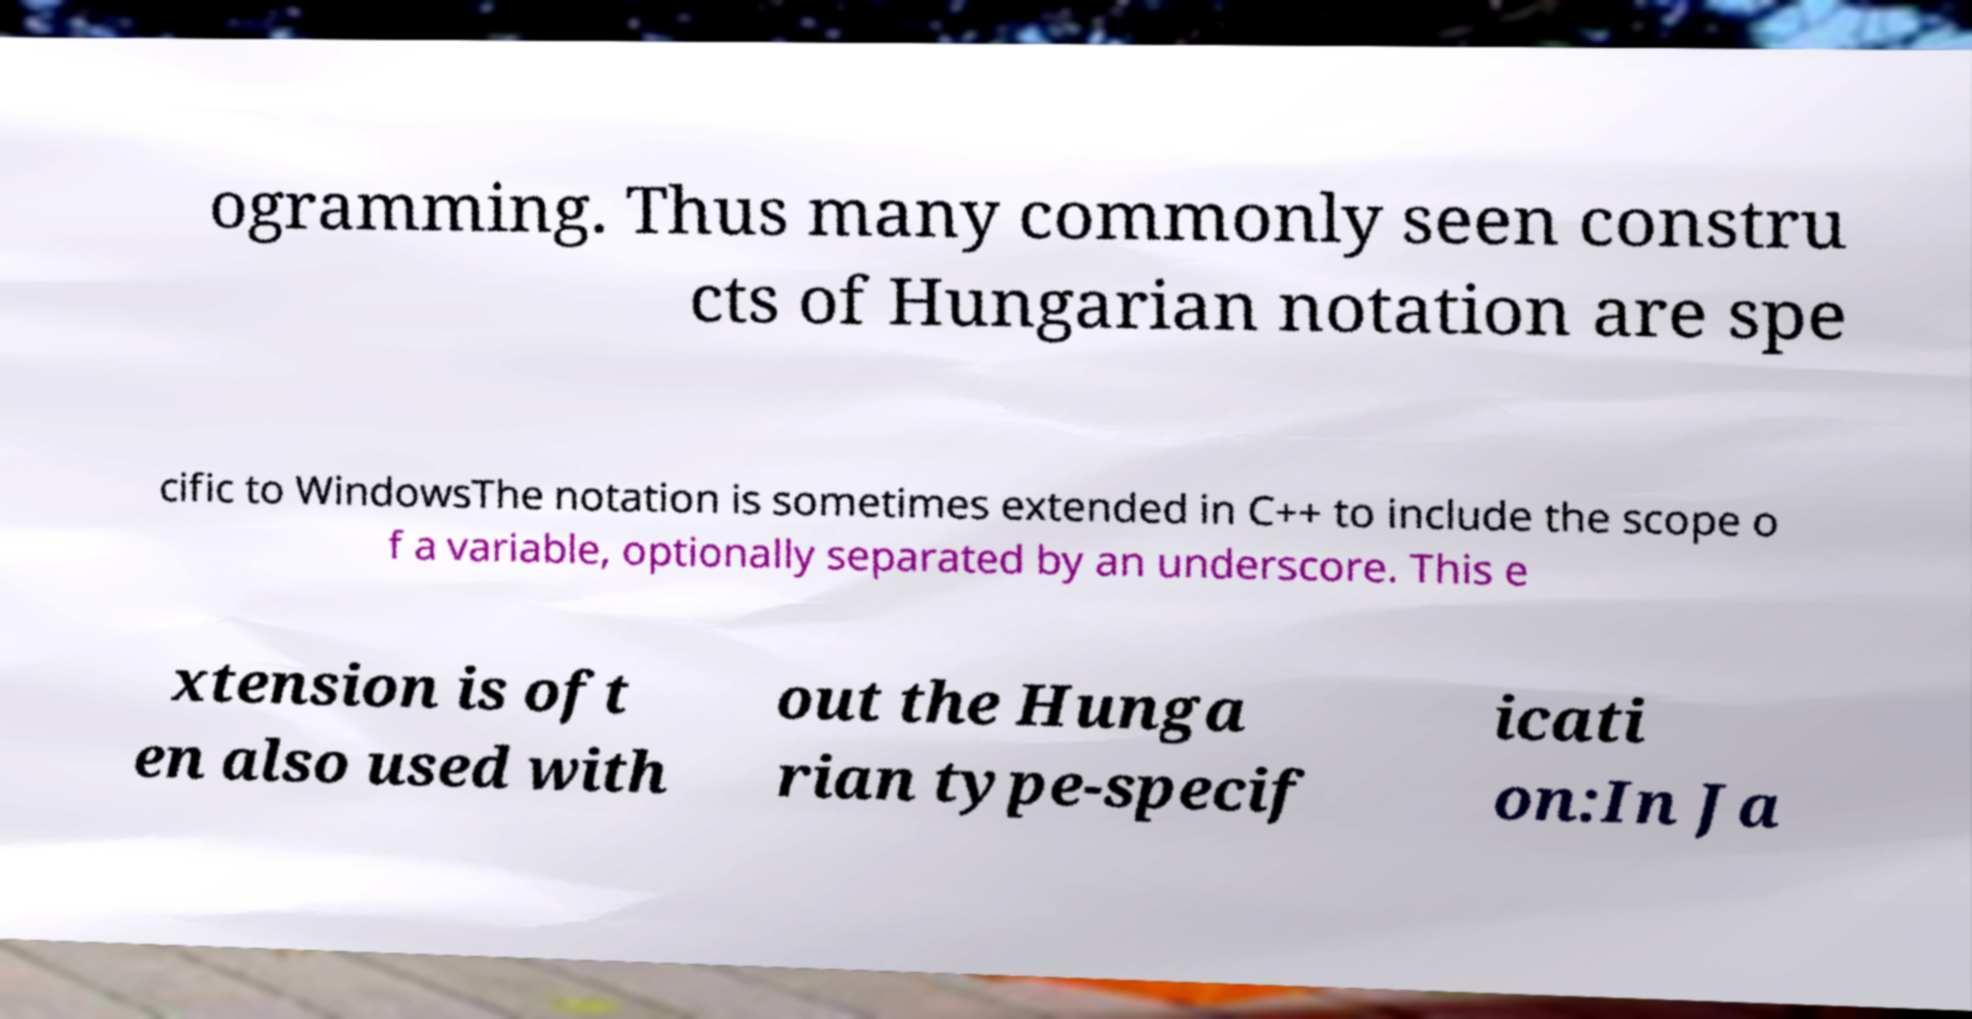For documentation purposes, I need the text within this image transcribed. Could you provide that? ogramming. Thus many commonly seen constru cts of Hungarian notation are spe cific to WindowsThe notation is sometimes extended in C++ to include the scope o f a variable, optionally separated by an underscore. This e xtension is oft en also used with out the Hunga rian type-specif icati on:In Ja 